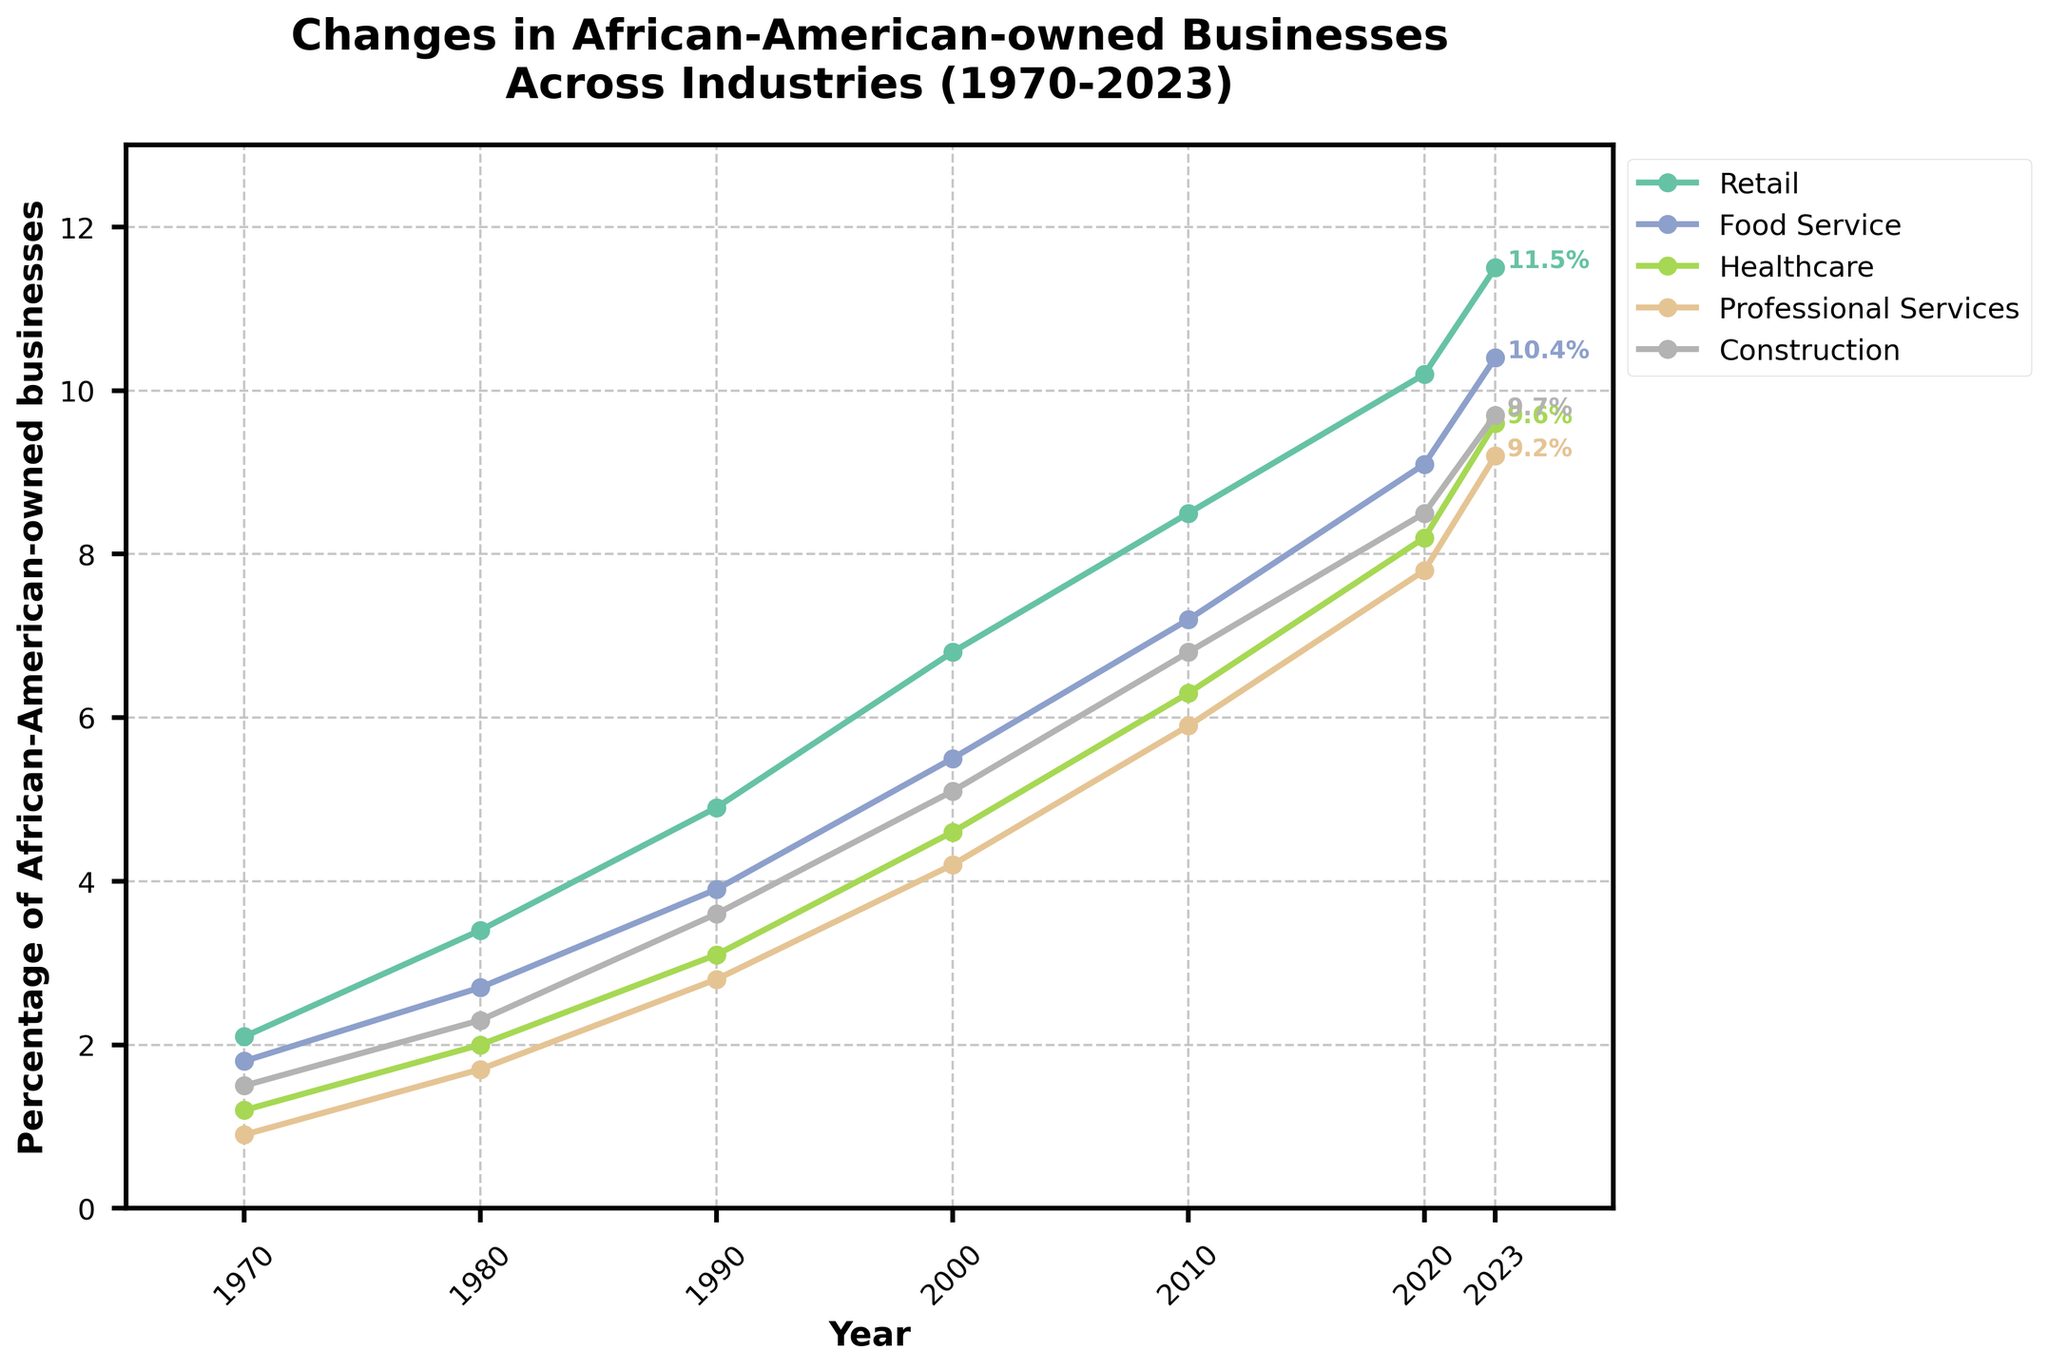What industry experienced the highest growth percentage of African-American-owned businesses from 1970 to 2023? Look at the data values for each industry in both 1970 and 2023 and calculate the difference. The highest growth percentage is in the Healthcare industry (from 1.2% to 9.6%).
Answer: Healthcare Which year saw the largest increase in the percentage of African-American-owned businesses in the Food Service industry? Compare the year-over-year increases for the Food Service data points from 1970 to 2023. The largest year-over-year increase occurs between 1970 and 1980 (1.8% to 2.7%).
Answer: 1980 How did the percentage of African-American-owned retail businesses change between 2000 and 2023? Subtract the 2000 value from the 2023 value for Retail (11.5% - 6.8%). The change is an increase of 4.7%.
Answer: 4.7% In what year did Professional Services pass the 5% mark in the percentage of African-American-owned businesses? By visually checking the plot, observe the trend line for Professional Services. It crosses the 5% mark between 2000 and 2010, so this indicates 2010.
Answer: 2010 Is the trend for African-American-owned Construction businesses always increasing, or are there any periods of stagnation or decline? Observe the trajectory of the Construction line. It continuously increases, which means there's no period of stagnation or decline.
Answer: Always increasing What two industries had the closest percentage of African-American-owned businesses in 1980? Compare the 1980 values for all industries. Food Service and Healthcare (2.7% and 2.0%) are the closest.
Answer: Food Service and Healthcare By how much did the percentage of African-American-owned businesses in the Professional Services industry change from 1990 to 2010? Subtract the 1990 value from the 2010 value for Professional Services (5.9% - 2.8%) to get the change of 3.1%.
Answer: 3.1% Which industry had the slowest growth in terms of percentage points from 1970 to 1990? Calculate the growth for each industry between 1970 and 1990 and identify the smallest value. The slowest growth rate was in the Healthcare industry (1.2% to 3.1%, a change of 1.9%).
Answer: Healthcare In what color is the Food Service industry line represented in the plot? Determine the color of the Food Service line by visually inspecting the plot.
Answer: [Answer based on plot visual] Which industry showed the most stable, steady increase (least fluctuations) over the entire period? By looking at the plot, see which line appears the most smooth without sharp increases or decreases. The Construction industry line appears the most steady.
Answer: Construction 